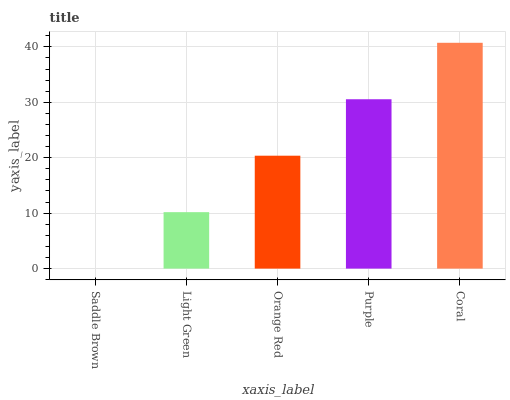Is Saddle Brown the minimum?
Answer yes or no. Yes. Is Coral the maximum?
Answer yes or no. Yes. Is Light Green the minimum?
Answer yes or no. No. Is Light Green the maximum?
Answer yes or no. No. Is Light Green greater than Saddle Brown?
Answer yes or no. Yes. Is Saddle Brown less than Light Green?
Answer yes or no. Yes. Is Saddle Brown greater than Light Green?
Answer yes or no. No. Is Light Green less than Saddle Brown?
Answer yes or no. No. Is Orange Red the high median?
Answer yes or no. Yes. Is Orange Red the low median?
Answer yes or no. Yes. Is Purple the high median?
Answer yes or no. No. Is Coral the low median?
Answer yes or no. No. 